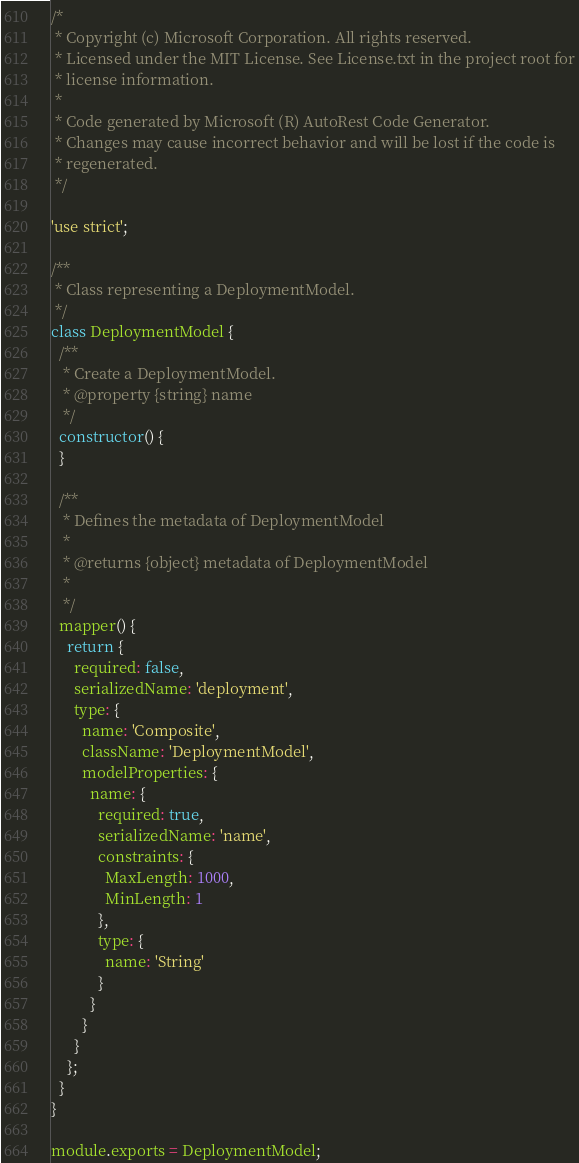Convert code to text. <code><loc_0><loc_0><loc_500><loc_500><_JavaScript_>/*
 * Copyright (c) Microsoft Corporation. All rights reserved.
 * Licensed under the MIT License. See License.txt in the project root for
 * license information.
 *
 * Code generated by Microsoft (R) AutoRest Code Generator.
 * Changes may cause incorrect behavior and will be lost if the code is
 * regenerated.
 */

'use strict';

/**
 * Class representing a DeploymentModel.
 */
class DeploymentModel {
  /**
   * Create a DeploymentModel.
   * @property {string} name
   */
  constructor() {
  }

  /**
   * Defines the metadata of DeploymentModel
   *
   * @returns {object} metadata of DeploymentModel
   *
   */
  mapper() {
    return {
      required: false,
      serializedName: 'deployment',
      type: {
        name: 'Composite',
        className: 'DeploymentModel',
        modelProperties: {
          name: {
            required: true,
            serializedName: 'name',
            constraints: {
              MaxLength: 1000,
              MinLength: 1
            },
            type: {
              name: 'String'
            }
          }
        }
      }
    };
  }
}

module.exports = DeploymentModel;
</code> 